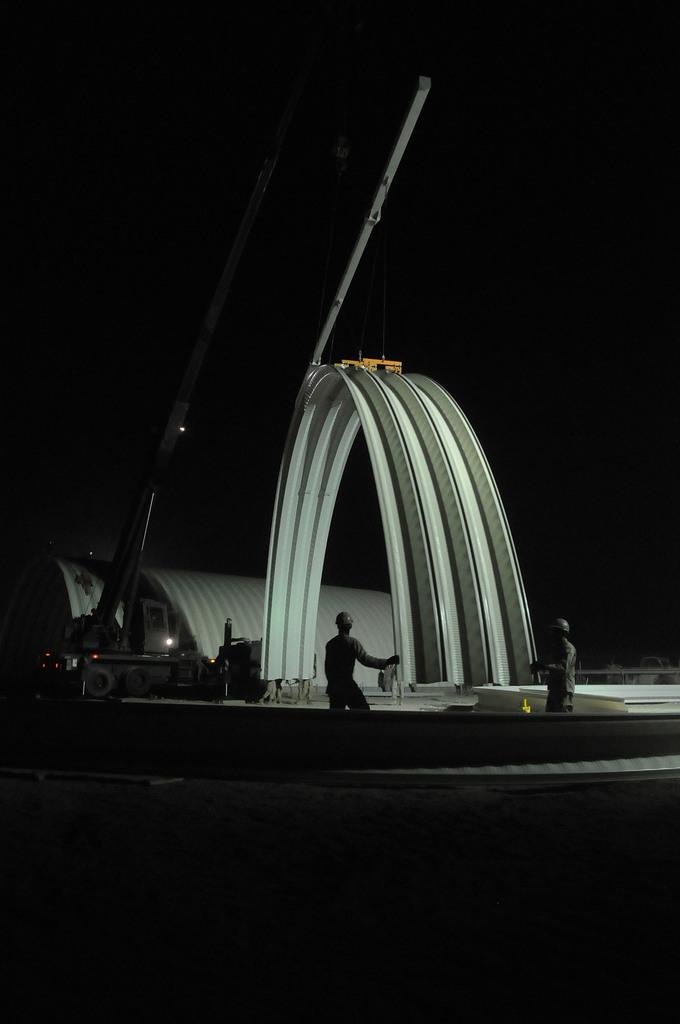What type of architectural feature is present in the image? There are arches in the image. Are there any living beings in the image? Yes, there are people in the image. What type of machinery can be seen in the image? There is a crane in the image. How was the image captured? The image is a night vision picture. How many rabbits can be seen hopping around in the image? There are no rabbits present in the image. What type of comfort can be provided by the arches in the image? The arches in the image are architectural features and do not provide comfort. 